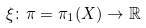<formula> <loc_0><loc_0><loc_500><loc_500>\xi \colon \pi = \pi _ { 1 } ( X ) \to \mathbb { R }</formula> 